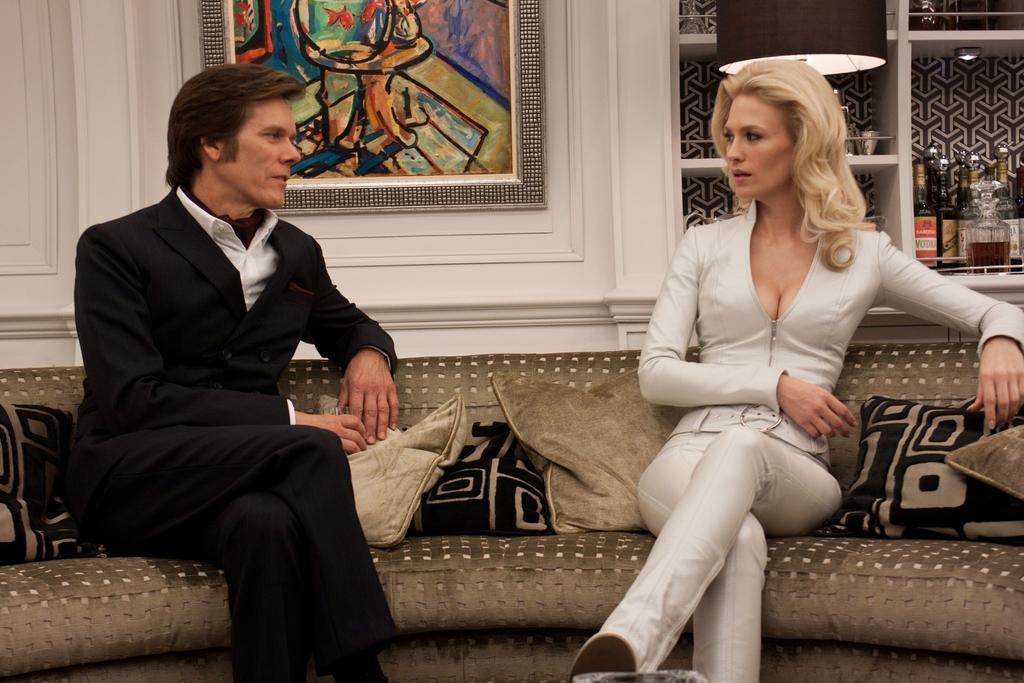Can you describe this image briefly? There is a room. They are sitting on a sofa. They are talking. There is a sofa. There is a pillow on a sofa. We can see in background photo frame and cupboard. There is wine bottles on a cupboard. 